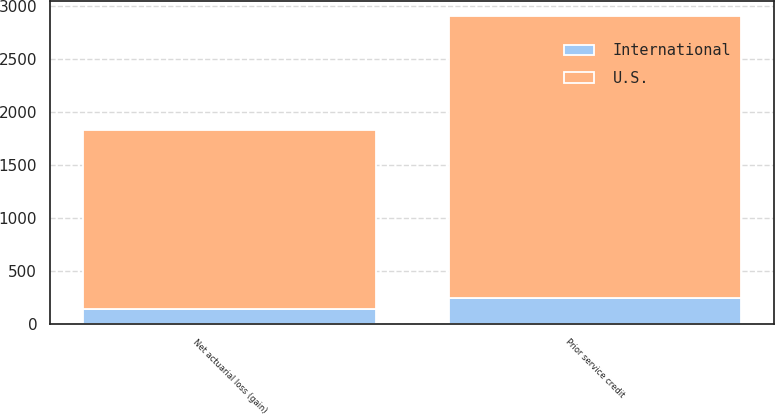Convert chart. <chart><loc_0><loc_0><loc_500><loc_500><stacked_bar_chart><ecel><fcel>Prior service credit<fcel>Net actuarial loss (gain)<nl><fcel>U.S.<fcel>2661<fcel>1684<nl><fcel>International<fcel>241<fcel>142<nl></chart> 